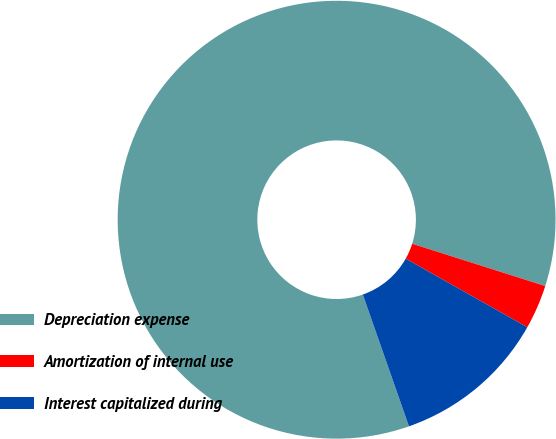Convert chart. <chart><loc_0><loc_0><loc_500><loc_500><pie_chart><fcel>Depreciation expense<fcel>Amortization of internal use<fcel>Interest capitalized during<nl><fcel>85.26%<fcel>3.27%<fcel>11.47%<nl></chart> 